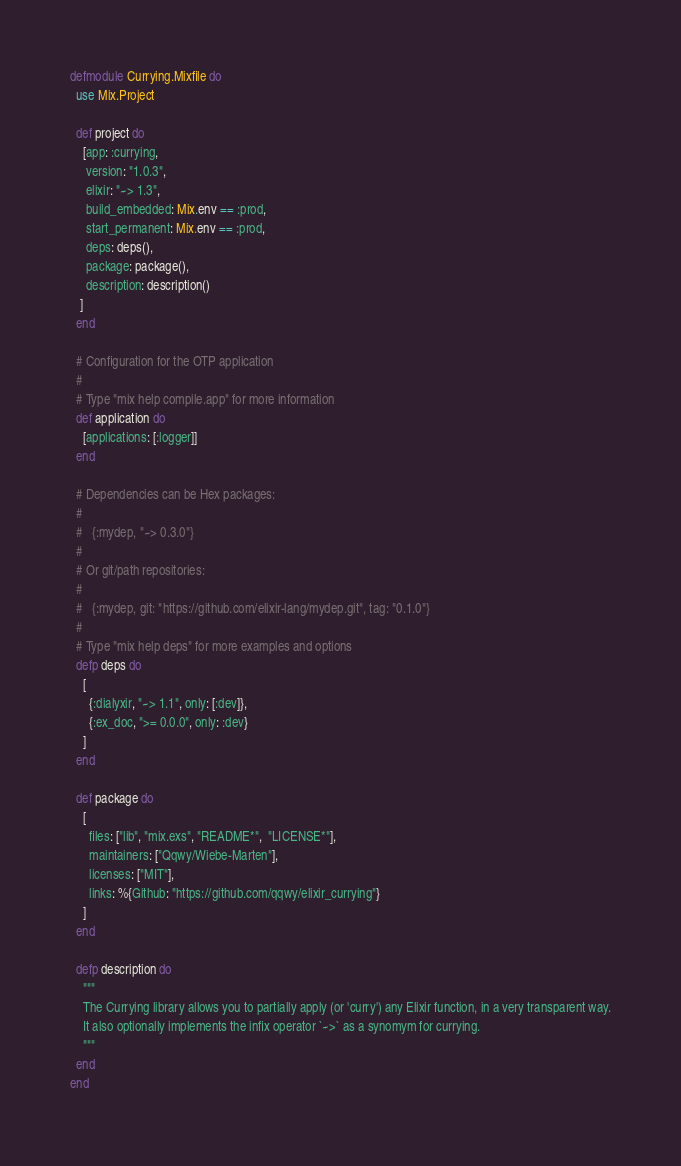Convert code to text. <code><loc_0><loc_0><loc_500><loc_500><_Elixir_>defmodule Currying.Mixfile do
  use Mix.Project

  def project do
    [app: :currying,
     version: "1.0.3",
     elixir: "~> 1.3",
     build_embedded: Mix.env == :prod,
     start_permanent: Mix.env == :prod,
     deps: deps(),
     package: package(),
     description: description()
   ]
  end

  # Configuration for the OTP application
  #
  # Type "mix help compile.app" for more information
  def application do
    [applications: [:logger]]
  end

  # Dependencies can be Hex packages:
  #
  #   {:mydep, "~> 0.3.0"}
  #
  # Or git/path repositories:
  #
  #   {:mydep, git: "https://github.com/elixir-lang/mydep.git", tag: "0.1.0"}
  #
  # Type "mix help deps" for more examples and options
  defp deps do
    [
      {:dialyxir, "~> 1.1", only: [:dev]},
      {:ex_doc, ">= 0.0.0", only: :dev}
    ]
  end

  def package do
    [
      files: ["lib", "mix.exs", "README*",  "LICENSE*"],
      maintainers: ["Qqwy/Wiebe-Marten"],
      licenses: ["MIT"],
      links: %{Github: "https://github.com/qqwy/elixir_currying"} 
    ]
  end

  defp description do
    """
    The Currying library allows you to partially apply (or 'curry') any Elixir function, in a very transparent way.
    It also optionally implements the infix operator `~>` as a synomym for currying.
    """
  end
end
</code> 